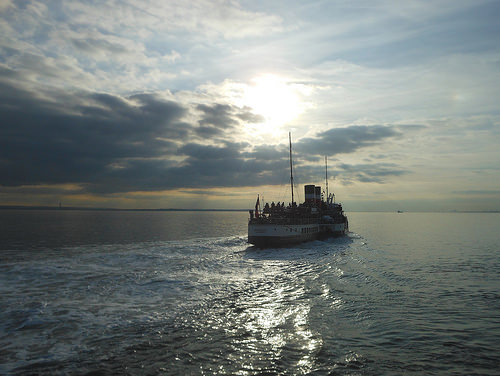<image>
Is there a sky behind the ship? Yes. From this viewpoint, the sky is positioned behind the ship, with the ship partially or fully occluding the sky. 